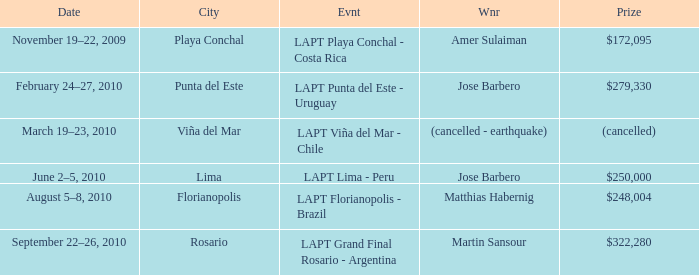What event is in florianopolis? LAPT Florianopolis - Brazil. 